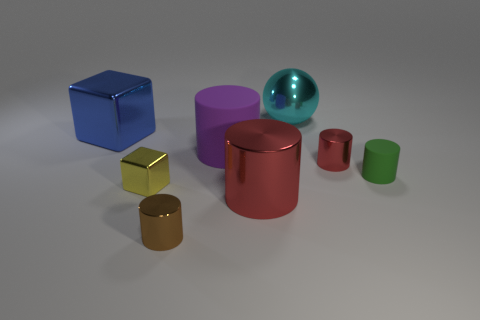Are there more green things that are in front of the purple matte thing than metal cylinders?
Ensure brevity in your answer.  No. What is the color of the big metal cylinder?
Ensure brevity in your answer.  Red. There is a red shiny object that is in front of the object that is right of the red shiny cylinder that is behind the green matte object; what shape is it?
Your answer should be very brief. Cylinder. What is the material of the thing that is behind the big purple cylinder and on the right side of the big purple cylinder?
Ensure brevity in your answer.  Metal. What shape is the red thing that is left of the small metallic thing that is to the right of the cyan metallic ball?
Your response must be concise. Cylinder. Is there any other thing of the same color as the large shiny cylinder?
Your response must be concise. Yes. There is a yellow object; does it have the same size as the metal cylinder that is behind the small yellow metallic block?
Provide a succinct answer. Yes. What number of big things are spheres or rubber cubes?
Your answer should be very brief. 1. Is the number of blue metallic things greater than the number of metallic cylinders?
Provide a succinct answer. No. What number of big cyan shiny objects are behind the red metallic cylinder that is behind the block in front of the large blue metal cube?
Keep it short and to the point. 1. 